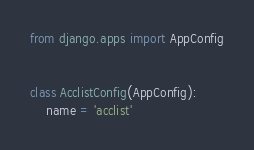Convert code to text. <code><loc_0><loc_0><loc_500><loc_500><_Python_>from django.apps import AppConfig


class AcclistConfig(AppConfig):
    name = 'acclist'
</code> 